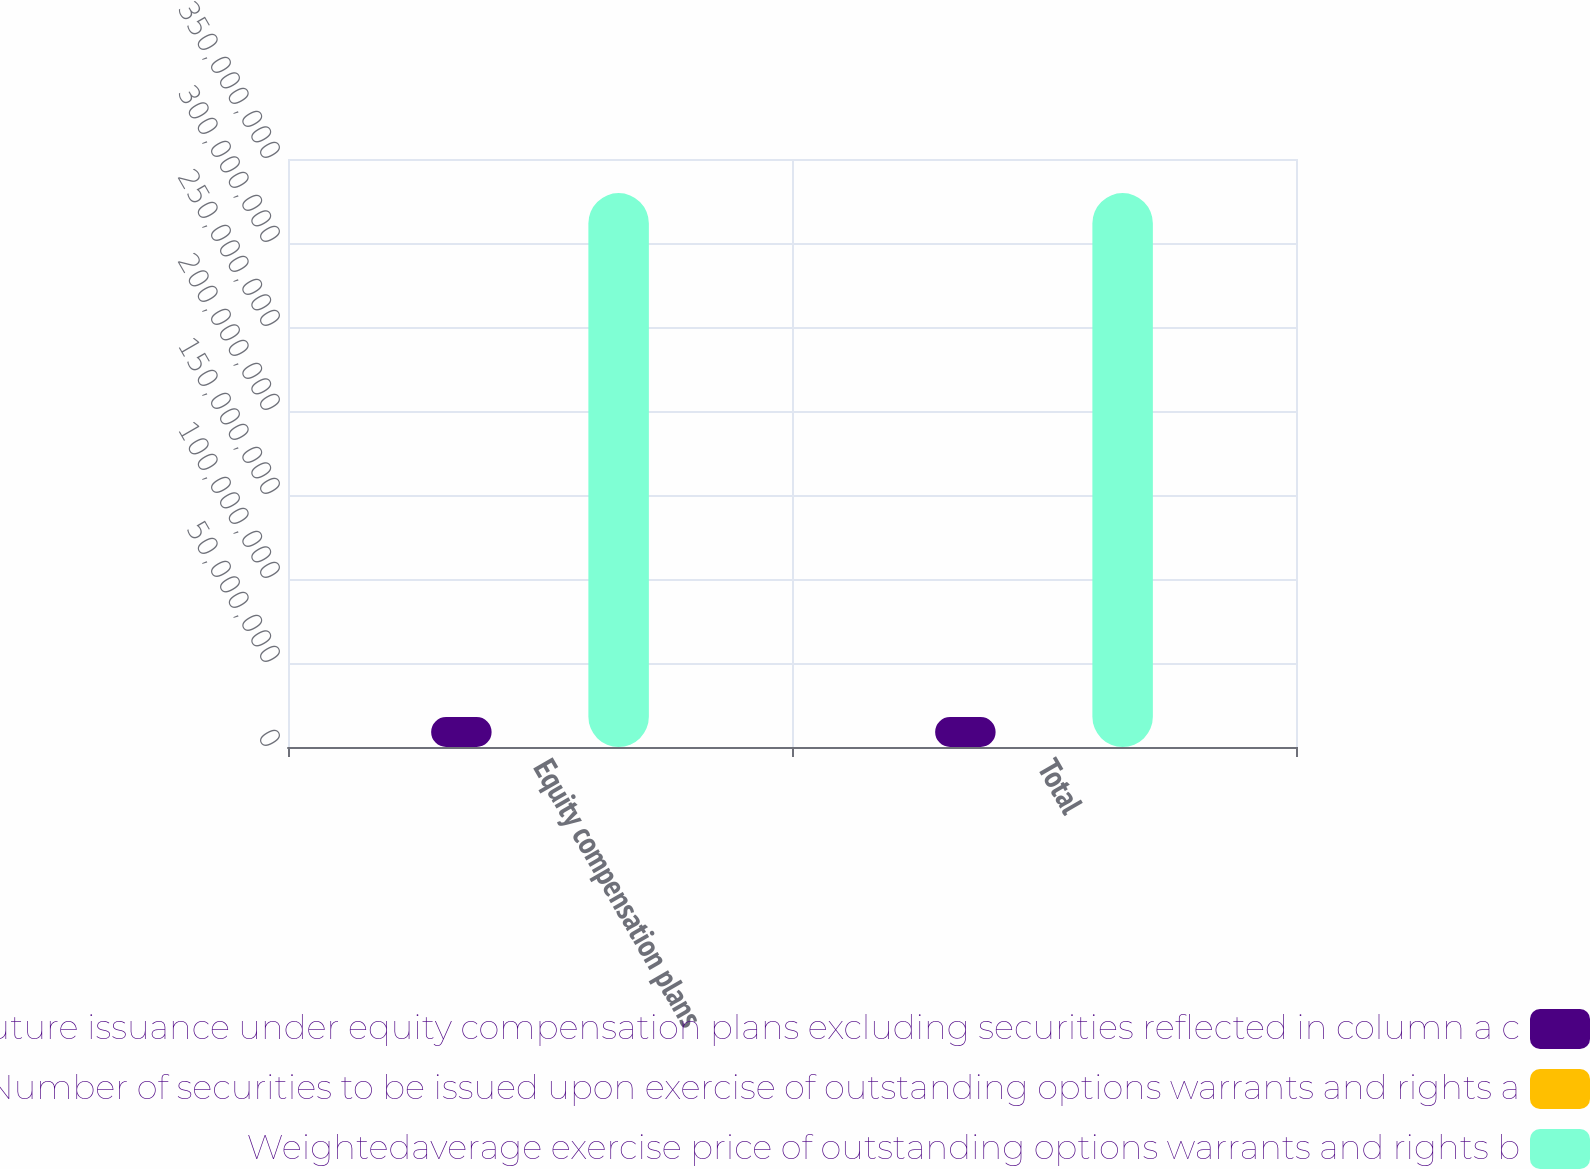Convert chart to OTSL. <chart><loc_0><loc_0><loc_500><loc_500><stacked_bar_chart><ecel><fcel>Equity compensation plans<fcel>Total<nl><fcel>Number of securities remaining available for future issuance under equity compensation plans excluding securities reflected in column a c<fcel>1.77984e+07<fcel>1.77984e+07<nl><fcel>Number of securities to be issued upon exercise of outstanding options warrants and rights a<fcel>15.11<fcel>15.11<nl><fcel>Weightedaverage exercise price of outstanding options warrants and rights b<fcel>3.297e+08<fcel>3.297e+08<nl></chart> 